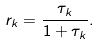<formula> <loc_0><loc_0><loc_500><loc_500>r _ { k } = \frac { \tau _ { k } } { 1 + \tau _ { k } } .</formula> 